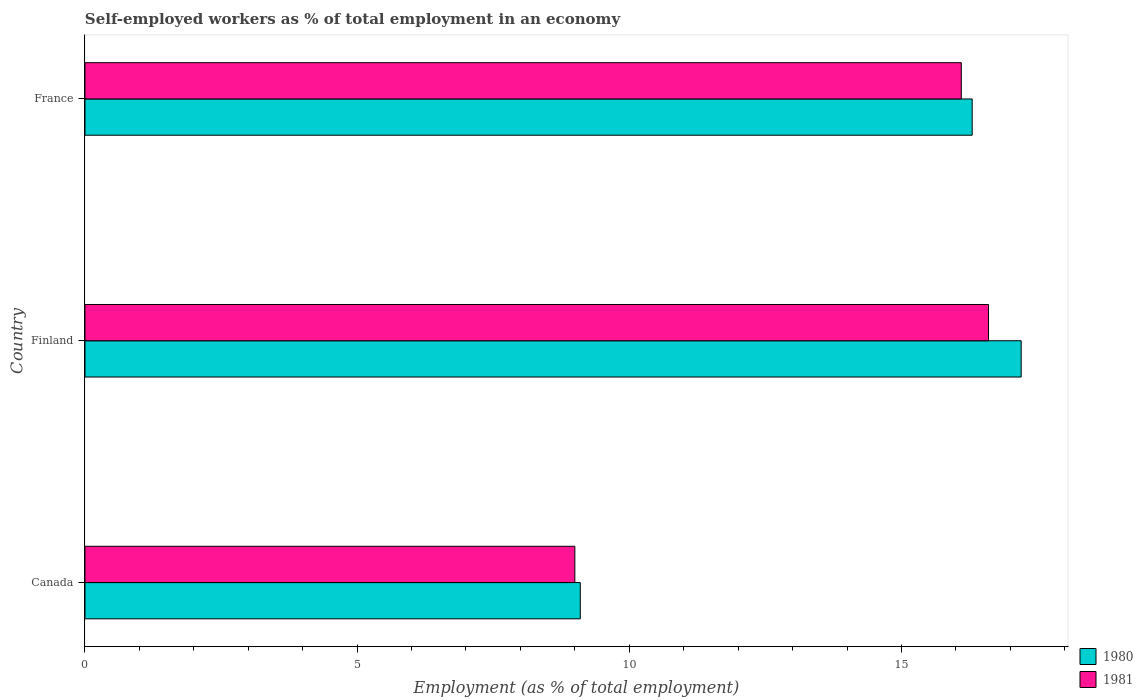How many different coloured bars are there?
Provide a short and direct response. 2. Are the number of bars per tick equal to the number of legend labels?
Provide a short and direct response. Yes. Are the number of bars on each tick of the Y-axis equal?
Provide a short and direct response. Yes. How many bars are there on the 3rd tick from the top?
Your answer should be compact. 2. How many bars are there on the 2nd tick from the bottom?
Keep it short and to the point. 2. What is the percentage of self-employed workers in 1981 in France?
Keep it short and to the point. 16.1. Across all countries, what is the maximum percentage of self-employed workers in 1980?
Give a very brief answer. 17.2. Across all countries, what is the minimum percentage of self-employed workers in 1981?
Offer a very short reply. 9. In which country was the percentage of self-employed workers in 1981 maximum?
Keep it short and to the point. Finland. In which country was the percentage of self-employed workers in 1981 minimum?
Make the answer very short. Canada. What is the total percentage of self-employed workers in 1980 in the graph?
Offer a very short reply. 42.6. What is the difference between the percentage of self-employed workers in 1980 in Finland and the percentage of self-employed workers in 1981 in Canada?
Keep it short and to the point. 8.2. What is the average percentage of self-employed workers in 1980 per country?
Your answer should be very brief. 14.2. What is the difference between the percentage of self-employed workers in 1980 and percentage of self-employed workers in 1981 in Finland?
Offer a terse response. 0.6. In how many countries, is the percentage of self-employed workers in 1981 greater than 8 %?
Provide a short and direct response. 3. What is the ratio of the percentage of self-employed workers in 1980 in Canada to that in France?
Make the answer very short. 0.56. What is the difference between the highest and the second highest percentage of self-employed workers in 1980?
Give a very brief answer. 0.9. What is the difference between the highest and the lowest percentage of self-employed workers in 1981?
Give a very brief answer. 7.6. What does the 1st bar from the top in Canada represents?
Provide a succinct answer. 1981. What does the 2nd bar from the bottom in Canada represents?
Offer a terse response. 1981. How many bars are there?
Your answer should be very brief. 6. Are all the bars in the graph horizontal?
Ensure brevity in your answer.  Yes. How many countries are there in the graph?
Provide a short and direct response. 3. What is the difference between two consecutive major ticks on the X-axis?
Your answer should be very brief. 5. How many legend labels are there?
Keep it short and to the point. 2. What is the title of the graph?
Offer a terse response. Self-employed workers as % of total employment in an economy. What is the label or title of the X-axis?
Offer a very short reply. Employment (as % of total employment). What is the label or title of the Y-axis?
Offer a very short reply. Country. What is the Employment (as % of total employment) of 1980 in Canada?
Make the answer very short. 9.1. What is the Employment (as % of total employment) of 1981 in Canada?
Give a very brief answer. 9. What is the Employment (as % of total employment) in 1980 in Finland?
Your answer should be very brief. 17.2. What is the Employment (as % of total employment) in 1981 in Finland?
Your answer should be very brief. 16.6. What is the Employment (as % of total employment) in 1980 in France?
Provide a succinct answer. 16.3. What is the Employment (as % of total employment) in 1981 in France?
Make the answer very short. 16.1. Across all countries, what is the maximum Employment (as % of total employment) of 1980?
Offer a very short reply. 17.2. Across all countries, what is the maximum Employment (as % of total employment) in 1981?
Offer a very short reply. 16.6. Across all countries, what is the minimum Employment (as % of total employment) of 1980?
Offer a terse response. 9.1. What is the total Employment (as % of total employment) in 1980 in the graph?
Your answer should be compact. 42.6. What is the total Employment (as % of total employment) in 1981 in the graph?
Make the answer very short. 41.7. What is the difference between the Employment (as % of total employment) in 1981 in Canada and that in France?
Your answer should be compact. -7.1. What is the difference between the Employment (as % of total employment) of 1980 in Finland and that in France?
Provide a short and direct response. 0.9. What is the difference between the Employment (as % of total employment) in 1980 in Canada and the Employment (as % of total employment) in 1981 in Finland?
Make the answer very short. -7.5. What is the difference between the Employment (as % of total employment) of 1980 in Canada and the Employment (as % of total employment) of 1981 in France?
Offer a very short reply. -7. What is the difference between the Employment (as % of total employment) of 1980 and Employment (as % of total employment) of 1981 in Canada?
Your answer should be compact. 0.1. What is the difference between the Employment (as % of total employment) in 1980 and Employment (as % of total employment) in 1981 in Finland?
Your answer should be very brief. 0.6. What is the ratio of the Employment (as % of total employment) of 1980 in Canada to that in Finland?
Your answer should be compact. 0.53. What is the ratio of the Employment (as % of total employment) of 1981 in Canada to that in Finland?
Ensure brevity in your answer.  0.54. What is the ratio of the Employment (as % of total employment) of 1980 in Canada to that in France?
Provide a succinct answer. 0.56. What is the ratio of the Employment (as % of total employment) in 1981 in Canada to that in France?
Your answer should be very brief. 0.56. What is the ratio of the Employment (as % of total employment) of 1980 in Finland to that in France?
Your response must be concise. 1.06. What is the ratio of the Employment (as % of total employment) in 1981 in Finland to that in France?
Your answer should be very brief. 1.03. What is the difference between the highest and the second highest Employment (as % of total employment) of 1980?
Provide a succinct answer. 0.9. What is the difference between the highest and the second highest Employment (as % of total employment) of 1981?
Provide a succinct answer. 0.5. 